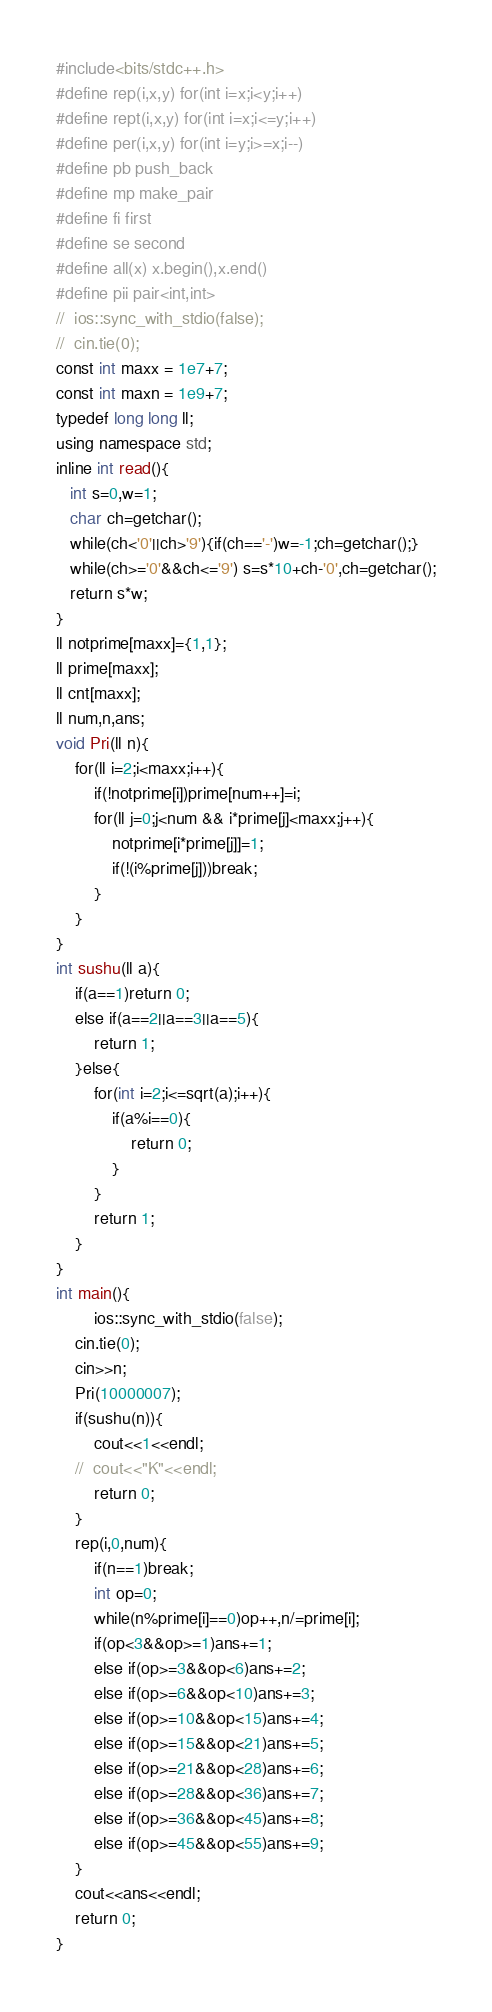<code> <loc_0><loc_0><loc_500><loc_500><_C++_>#include<bits/stdc++.h>
#define rep(i,x,y) for(int i=x;i<y;i++)
#define rept(i,x,y) for(int i=x;i<=y;i++)
#define per(i,x,y) for(int i=y;i>=x;i--)
#define pb push_back
#define mp make_pair
#define fi first
#define se second
#define all(x) x.begin(),x.end()
#define pii pair<int,int>
//	ios::sync_with_stdio(false);
//	cin.tie(0);
const int maxx = 1e7+7;
const int maxn = 1e9+7;
typedef long long ll;
using namespace std;
inline int read(){
   int s=0,w=1;
   char ch=getchar();
   while(ch<'0'||ch>'9'){if(ch=='-')w=-1;ch=getchar();}
   while(ch>='0'&&ch<='9') s=s*10+ch-'0',ch=getchar();
   return s*w;
}
ll notprime[maxx]={1,1};
ll prime[maxx];
ll cnt[maxx];
ll num,n,ans;
void Pri(ll n){
	for(ll i=2;i<maxx;i++){
		if(!notprime[i])prime[num++]=i;
		for(ll j=0;j<num && i*prime[j]<maxx;j++){
			notprime[i*prime[j]]=1;
			if(!(i%prime[j]))break;
		} 
	}
}
int sushu(ll a){
	if(a==1)return 0;
	else if(a==2||a==3||a==5){
		return 1;
	}else{
		for(int i=2;i<=sqrt(a);i++){
			if(a%i==0){
				return 0;
			}
		}
		return 1;
	}
}
int main(){
		ios::sync_with_stdio(false);
	cin.tie(0);
	cin>>n;
	Pri(10000007);
	if(sushu(n)){
		cout<<1<<endl;
	//	cout<<"K"<<endl;
		return 0;
	}
	rep(i,0,num){
		if(n==1)break;
		int op=0;
		while(n%prime[i]==0)op++,n/=prime[i];
		if(op<3&&op>=1)ans+=1;
		else if(op>=3&&op<6)ans+=2;
		else if(op>=6&&op<10)ans+=3;
		else if(op>=10&&op<15)ans+=4;
		else if(op>=15&&op<21)ans+=5;
		else if(op>=21&&op<28)ans+=6;
		else if(op>=28&&op<36)ans+=7;
		else if(op>=36&&op<45)ans+=8;
		else if(op>=45&&op<55)ans+=9;
	}
	cout<<ans<<endl;
	return 0;
}
</code> 